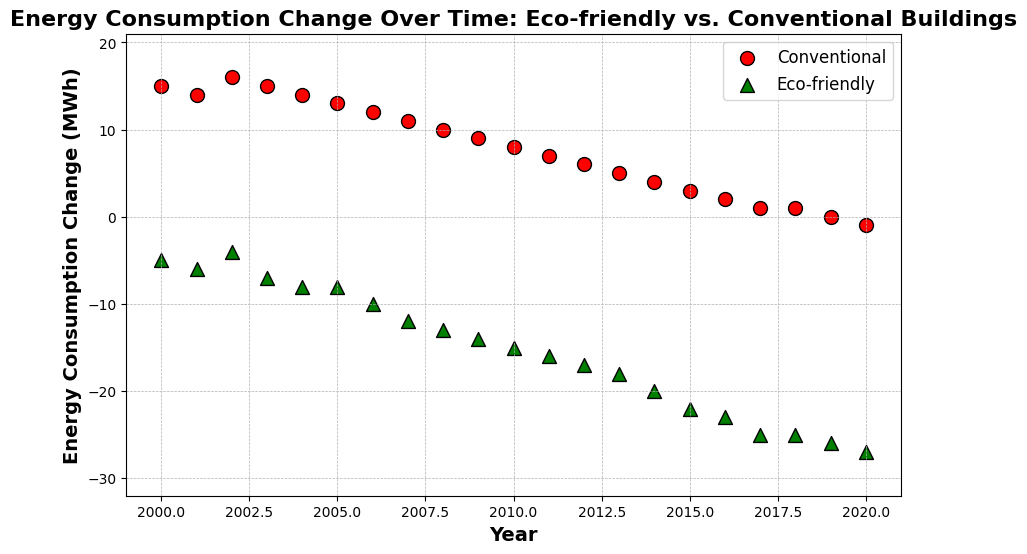What type of buildings have markers shaped like triangles? The markers shaped like triangles represent Eco-friendly buildings in the scatter plot.
Answer: Eco-friendly buildings How did the energy consumption change for Eco-friendly buildings between 2000 and 2020? In 2000, the energy consumption change for Eco-friendly buildings was -5, and in 2020, it was -27. Subtracting these values gives -27 - (-5) = -22, indicating a drop of 22 MWh.
Answer: -22 MWh Which building type shows a negative energy consumption change throughout the period? Eco-friendly buildings have consistently negative energy consumption changes as indicated by the green triangular markers below the horizontal axis in the scatter plot.
Answer: Eco-friendly buildings By how much did the energy consumption change for Conventional buildings from the year 2016 to 2020? In 2016, the energy consumption change for Conventional buildings was 2 MWh. In 2020, it was -1 MWh. The change is -1 - 2 = -3 MWh.
Answer: -3 MWh Between which years did Eco-friendly buildings show the largest decrease in energy consumption? Eco-friendly buildings had the most significant decrease from 2014 to 2015, changing from -20 to -22, a decrease of 2 MWh.
Answer: 2014 to 2015 How do the changes in energy consumption for Conventional buildings in 2008 compare to Eco-friendly buildings? In 2008, Conventional buildings had an energy consumption change of 10 MWh, while Eco-friendly buildings had a change of -13 MWh. The difference is 10 - (-13) = 23 MWh.
Answer: 23 MWh Which year shows the minimum energy consumption change for Conventional buildings and what is the value? The minimum energy consumption change for Conventional buildings occurs in 2020, with a value of -1 MWh as indicated by the red circular marker at -1 in 2020.
Answer: 2020, -1 MWh Which year shows Eco-friendly buildings reaching a change of -25 MWh for the first time? Eco-friendly buildings reached a change of -25 MWh in the year 2017 for the first time, as shown by the green triangular marker at -25 in 2017.
Answer: 2017 What is the difference in the energy consumption change between Conventional buildings in 2019 and 2020? In 2019, the energy consumption change for Conventional buildings was 0, and in 2020 it was -1. The difference is 0 - (-1) = 1 MWh.
Answer: 1 MWh 